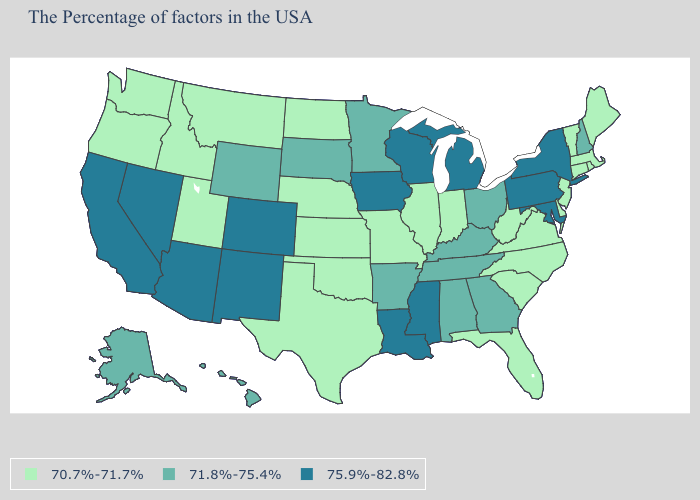Which states have the highest value in the USA?
Short answer required. New York, Maryland, Pennsylvania, Michigan, Wisconsin, Mississippi, Louisiana, Iowa, Colorado, New Mexico, Arizona, Nevada, California. Does Tennessee have the same value as New Jersey?
Quick response, please. No. What is the lowest value in states that border Delaware?
Keep it brief. 70.7%-71.7%. Which states hav the highest value in the MidWest?
Concise answer only. Michigan, Wisconsin, Iowa. What is the highest value in the USA?
Write a very short answer. 75.9%-82.8%. Name the states that have a value in the range 71.8%-75.4%?
Give a very brief answer. New Hampshire, Ohio, Georgia, Kentucky, Alabama, Tennessee, Arkansas, Minnesota, South Dakota, Wyoming, Alaska, Hawaii. Among the states that border Colorado , does Arizona have the highest value?
Be succinct. Yes. Does Michigan have the highest value in the USA?
Write a very short answer. Yes. Does the first symbol in the legend represent the smallest category?
Answer briefly. Yes. Which states have the lowest value in the USA?
Quick response, please. Maine, Massachusetts, Rhode Island, Vermont, Connecticut, New Jersey, Delaware, Virginia, North Carolina, South Carolina, West Virginia, Florida, Indiana, Illinois, Missouri, Kansas, Nebraska, Oklahoma, Texas, North Dakota, Utah, Montana, Idaho, Washington, Oregon. What is the lowest value in states that border Texas?
Short answer required. 70.7%-71.7%. What is the value of Iowa?
Be succinct. 75.9%-82.8%. Does the map have missing data?
Give a very brief answer. No. Among the states that border Vermont , does Massachusetts have the lowest value?
Concise answer only. Yes. Does Oregon have the lowest value in the USA?
Short answer required. Yes. 